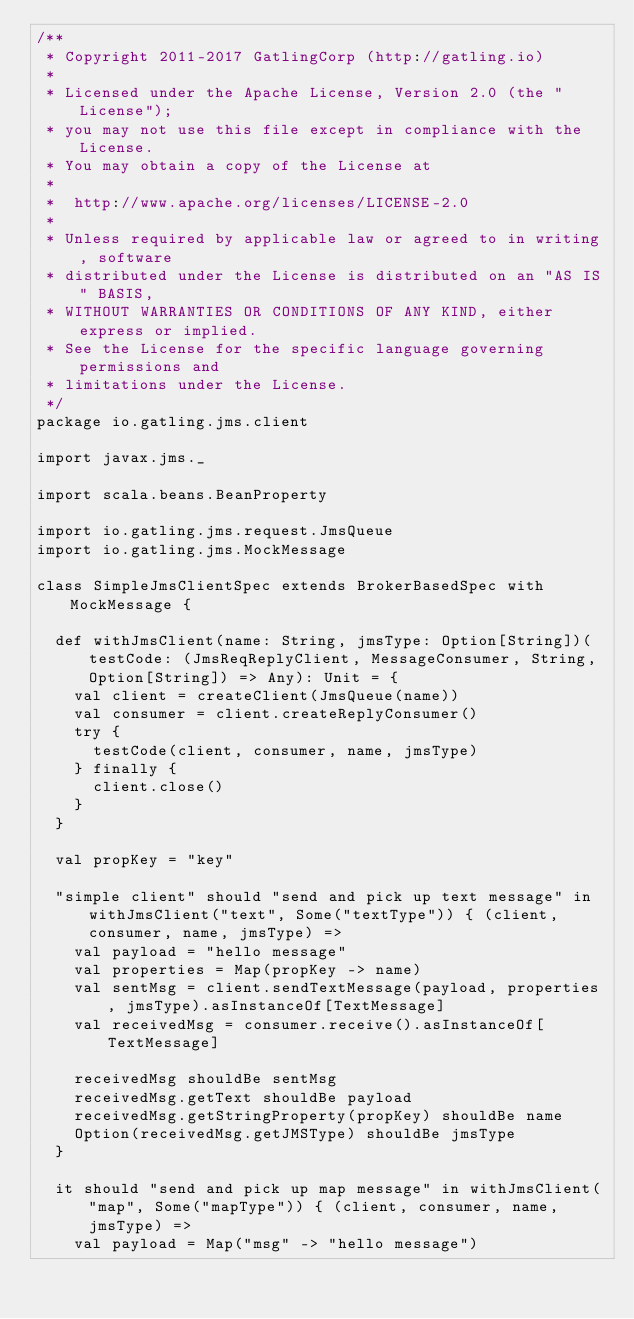<code> <loc_0><loc_0><loc_500><loc_500><_Scala_>/**
 * Copyright 2011-2017 GatlingCorp (http://gatling.io)
 *
 * Licensed under the Apache License, Version 2.0 (the "License");
 * you may not use this file except in compliance with the License.
 * You may obtain a copy of the License at
 *
 *  http://www.apache.org/licenses/LICENSE-2.0
 *
 * Unless required by applicable law or agreed to in writing, software
 * distributed under the License is distributed on an "AS IS" BASIS,
 * WITHOUT WARRANTIES OR CONDITIONS OF ANY KIND, either express or implied.
 * See the License for the specific language governing permissions and
 * limitations under the License.
 */
package io.gatling.jms.client

import javax.jms._

import scala.beans.BeanProperty

import io.gatling.jms.request.JmsQueue
import io.gatling.jms.MockMessage

class SimpleJmsClientSpec extends BrokerBasedSpec with MockMessage {

  def withJmsClient(name: String, jmsType: Option[String])(testCode: (JmsReqReplyClient, MessageConsumer, String, Option[String]) => Any): Unit = {
    val client = createClient(JmsQueue(name))
    val consumer = client.createReplyConsumer()
    try {
      testCode(client, consumer, name, jmsType)
    } finally {
      client.close()
    }
  }

  val propKey = "key"

  "simple client" should "send and pick up text message" in withJmsClient("text", Some("textType")) { (client, consumer, name, jmsType) =>
    val payload = "hello message"
    val properties = Map(propKey -> name)
    val sentMsg = client.sendTextMessage(payload, properties, jmsType).asInstanceOf[TextMessage]
    val receivedMsg = consumer.receive().asInstanceOf[TextMessage]

    receivedMsg shouldBe sentMsg
    receivedMsg.getText shouldBe payload
    receivedMsg.getStringProperty(propKey) shouldBe name
    Option(receivedMsg.getJMSType) shouldBe jmsType
  }

  it should "send and pick up map message" in withJmsClient("map", Some("mapType")) { (client, consumer, name, jmsType) =>
    val payload = Map("msg" -> "hello message")</code> 